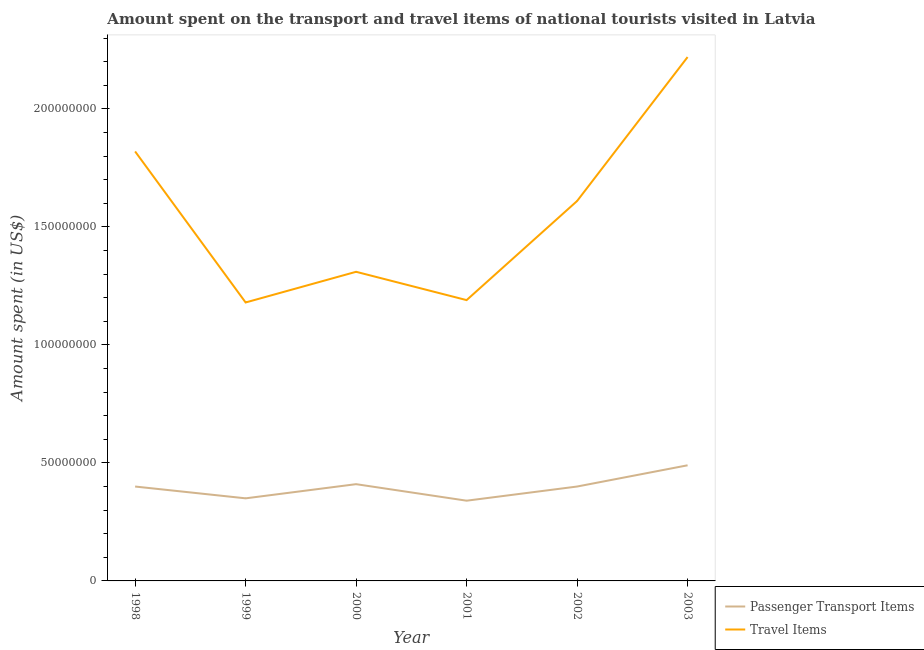Does the line corresponding to amount spent on passenger transport items intersect with the line corresponding to amount spent in travel items?
Your answer should be compact. No. What is the amount spent in travel items in 2000?
Keep it short and to the point. 1.31e+08. Across all years, what is the maximum amount spent in travel items?
Make the answer very short. 2.22e+08. Across all years, what is the minimum amount spent on passenger transport items?
Provide a succinct answer. 3.40e+07. In which year was the amount spent in travel items maximum?
Offer a very short reply. 2003. What is the total amount spent on passenger transport items in the graph?
Make the answer very short. 2.39e+08. What is the difference between the amount spent in travel items in 2000 and that in 2002?
Give a very brief answer. -3.00e+07. What is the difference between the amount spent on passenger transport items in 2002 and the amount spent in travel items in 2000?
Provide a short and direct response. -9.10e+07. What is the average amount spent on passenger transport items per year?
Give a very brief answer. 3.98e+07. In the year 2001, what is the difference between the amount spent on passenger transport items and amount spent in travel items?
Your answer should be compact. -8.50e+07. What is the ratio of the amount spent in travel items in 1998 to that in 2003?
Your answer should be very brief. 0.82. Is the difference between the amount spent in travel items in 2000 and 2001 greater than the difference between the amount spent on passenger transport items in 2000 and 2001?
Ensure brevity in your answer.  Yes. What is the difference between the highest and the second highest amount spent in travel items?
Keep it short and to the point. 4.00e+07. What is the difference between the highest and the lowest amount spent in travel items?
Offer a terse response. 1.04e+08. Is the sum of the amount spent on passenger transport items in 1998 and 2002 greater than the maximum amount spent in travel items across all years?
Your answer should be compact. No. Is the amount spent on passenger transport items strictly greater than the amount spent in travel items over the years?
Your response must be concise. No. What is the difference between two consecutive major ticks on the Y-axis?
Your answer should be compact. 5.00e+07. How many legend labels are there?
Ensure brevity in your answer.  2. What is the title of the graph?
Keep it short and to the point. Amount spent on the transport and travel items of national tourists visited in Latvia. Does "Research and Development" appear as one of the legend labels in the graph?
Provide a short and direct response. No. What is the label or title of the Y-axis?
Make the answer very short. Amount spent (in US$). What is the Amount spent (in US$) in Passenger Transport Items in 1998?
Your answer should be compact. 4.00e+07. What is the Amount spent (in US$) of Travel Items in 1998?
Your answer should be compact. 1.82e+08. What is the Amount spent (in US$) in Passenger Transport Items in 1999?
Your answer should be compact. 3.50e+07. What is the Amount spent (in US$) of Travel Items in 1999?
Offer a terse response. 1.18e+08. What is the Amount spent (in US$) of Passenger Transport Items in 2000?
Offer a terse response. 4.10e+07. What is the Amount spent (in US$) in Travel Items in 2000?
Offer a terse response. 1.31e+08. What is the Amount spent (in US$) of Passenger Transport Items in 2001?
Offer a very short reply. 3.40e+07. What is the Amount spent (in US$) in Travel Items in 2001?
Make the answer very short. 1.19e+08. What is the Amount spent (in US$) of Passenger Transport Items in 2002?
Provide a short and direct response. 4.00e+07. What is the Amount spent (in US$) of Travel Items in 2002?
Provide a short and direct response. 1.61e+08. What is the Amount spent (in US$) of Passenger Transport Items in 2003?
Your answer should be compact. 4.90e+07. What is the Amount spent (in US$) in Travel Items in 2003?
Provide a succinct answer. 2.22e+08. Across all years, what is the maximum Amount spent (in US$) in Passenger Transport Items?
Offer a terse response. 4.90e+07. Across all years, what is the maximum Amount spent (in US$) in Travel Items?
Give a very brief answer. 2.22e+08. Across all years, what is the minimum Amount spent (in US$) of Passenger Transport Items?
Give a very brief answer. 3.40e+07. Across all years, what is the minimum Amount spent (in US$) in Travel Items?
Give a very brief answer. 1.18e+08. What is the total Amount spent (in US$) in Passenger Transport Items in the graph?
Your response must be concise. 2.39e+08. What is the total Amount spent (in US$) in Travel Items in the graph?
Provide a short and direct response. 9.33e+08. What is the difference between the Amount spent (in US$) of Passenger Transport Items in 1998 and that in 1999?
Your answer should be compact. 5.00e+06. What is the difference between the Amount spent (in US$) of Travel Items in 1998 and that in 1999?
Your response must be concise. 6.40e+07. What is the difference between the Amount spent (in US$) in Passenger Transport Items in 1998 and that in 2000?
Give a very brief answer. -1.00e+06. What is the difference between the Amount spent (in US$) in Travel Items in 1998 and that in 2000?
Offer a terse response. 5.10e+07. What is the difference between the Amount spent (in US$) in Travel Items in 1998 and that in 2001?
Keep it short and to the point. 6.30e+07. What is the difference between the Amount spent (in US$) of Travel Items in 1998 and that in 2002?
Give a very brief answer. 2.10e+07. What is the difference between the Amount spent (in US$) of Passenger Transport Items in 1998 and that in 2003?
Your response must be concise. -9.00e+06. What is the difference between the Amount spent (in US$) of Travel Items in 1998 and that in 2003?
Provide a short and direct response. -4.00e+07. What is the difference between the Amount spent (in US$) in Passenger Transport Items in 1999 and that in 2000?
Offer a terse response. -6.00e+06. What is the difference between the Amount spent (in US$) in Travel Items in 1999 and that in 2000?
Provide a succinct answer. -1.30e+07. What is the difference between the Amount spent (in US$) of Travel Items in 1999 and that in 2001?
Give a very brief answer. -1.00e+06. What is the difference between the Amount spent (in US$) in Passenger Transport Items in 1999 and that in 2002?
Your answer should be compact. -5.00e+06. What is the difference between the Amount spent (in US$) of Travel Items in 1999 and that in 2002?
Provide a succinct answer. -4.30e+07. What is the difference between the Amount spent (in US$) in Passenger Transport Items in 1999 and that in 2003?
Give a very brief answer. -1.40e+07. What is the difference between the Amount spent (in US$) of Travel Items in 1999 and that in 2003?
Ensure brevity in your answer.  -1.04e+08. What is the difference between the Amount spent (in US$) of Passenger Transport Items in 2000 and that in 2002?
Give a very brief answer. 1.00e+06. What is the difference between the Amount spent (in US$) in Travel Items in 2000 and that in 2002?
Your response must be concise. -3.00e+07. What is the difference between the Amount spent (in US$) of Passenger Transport Items in 2000 and that in 2003?
Provide a succinct answer. -8.00e+06. What is the difference between the Amount spent (in US$) in Travel Items in 2000 and that in 2003?
Offer a very short reply. -9.10e+07. What is the difference between the Amount spent (in US$) in Passenger Transport Items in 2001 and that in 2002?
Your answer should be compact. -6.00e+06. What is the difference between the Amount spent (in US$) in Travel Items in 2001 and that in 2002?
Give a very brief answer. -4.20e+07. What is the difference between the Amount spent (in US$) of Passenger Transport Items in 2001 and that in 2003?
Your answer should be compact. -1.50e+07. What is the difference between the Amount spent (in US$) of Travel Items in 2001 and that in 2003?
Make the answer very short. -1.03e+08. What is the difference between the Amount spent (in US$) of Passenger Transport Items in 2002 and that in 2003?
Offer a terse response. -9.00e+06. What is the difference between the Amount spent (in US$) in Travel Items in 2002 and that in 2003?
Ensure brevity in your answer.  -6.10e+07. What is the difference between the Amount spent (in US$) in Passenger Transport Items in 1998 and the Amount spent (in US$) in Travel Items in 1999?
Give a very brief answer. -7.80e+07. What is the difference between the Amount spent (in US$) in Passenger Transport Items in 1998 and the Amount spent (in US$) in Travel Items in 2000?
Make the answer very short. -9.10e+07. What is the difference between the Amount spent (in US$) in Passenger Transport Items in 1998 and the Amount spent (in US$) in Travel Items in 2001?
Give a very brief answer. -7.90e+07. What is the difference between the Amount spent (in US$) of Passenger Transport Items in 1998 and the Amount spent (in US$) of Travel Items in 2002?
Give a very brief answer. -1.21e+08. What is the difference between the Amount spent (in US$) of Passenger Transport Items in 1998 and the Amount spent (in US$) of Travel Items in 2003?
Your answer should be very brief. -1.82e+08. What is the difference between the Amount spent (in US$) of Passenger Transport Items in 1999 and the Amount spent (in US$) of Travel Items in 2000?
Keep it short and to the point. -9.60e+07. What is the difference between the Amount spent (in US$) of Passenger Transport Items in 1999 and the Amount spent (in US$) of Travel Items in 2001?
Offer a very short reply. -8.40e+07. What is the difference between the Amount spent (in US$) of Passenger Transport Items in 1999 and the Amount spent (in US$) of Travel Items in 2002?
Ensure brevity in your answer.  -1.26e+08. What is the difference between the Amount spent (in US$) of Passenger Transport Items in 1999 and the Amount spent (in US$) of Travel Items in 2003?
Provide a succinct answer. -1.87e+08. What is the difference between the Amount spent (in US$) of Passenger Transport Items in 2000 and the Amount spent (in US$) of Travel Items in 2001?
Provide a short and direct response. -7.80e+07. What is the difference between the Amount spent (in US$) in Passenger Transport Items in 2000 and the Amount spent (in US$) in Travel Items in 2002?
Your response must be concise. -1.20e+08. What is the difference between the Amount spent (in US$) of Passenger Transport Items in 2000 and the Amount spent (in US$) of Travel Items in 2003?
Your answer should be compact. -1.81e+08. What is the difference between the Amount spent (in US$) of Passenger Transport Items in 2001 and the Amount spent (in US$) of Travel Items in 2002?
Keep it short and to the point. -1.27e+08. What is the difference between the Amount spent (in US$) of Passenger Transport Items in 2001 and the Amount spent (in US$) of Travel Items in 2003?
Offer a terse response. -1.88e+08. What is the difference between the Amount spent (in US$) in Passenger Transport Items in 2002 and the Amount spent (in US$) in Travel Items in 2003?
Keep it short and to the point. -1.82e+08. What is the average Amount spent (in US$) in Passenger Transport Items per year?
Provide a short and direct response. 3.98e+07. What is the average Amount spent (in US$) of Travel Items per year?
Ensure brevity in your answer.  1.56e+08. In the year 1998, what is the difference between the Amount spent (in US$) of Passenger Transport Items and Amount spent (in US$) of Travel Items?
Offer a very short reply. -1.42e+08. In the year 1999, what is the difference between the Amount spent (in US$) of Passenger Transport Items and Amount spent (in US$) of Travel Items?
Ensure brevity in your answer.  -8.30e+07. In the year 2000, what is the difference between the Amount spent (in US$) in Passenger Transport Items and Amount spent (in US$) in Travel Items?
Provide a succinct answer. -9.00e+07. In the year 2001, what is the difference between the Amount spent (in US$) in Passenger Transport Items and Amount spent (in US$) in Travel Items?
Offer a terse response. -8.50e+07. In the year 2002, what is the difference between the Amount spent (in US$) in Passenger Transport Items and Amount spent (in US$) in Travel Items?
Keep it short and to the point. -1.21e+08. In the year 2003, what is the difference between the Amount spent (in US$) in Passenger Transport Items and Amount spent (in US$) in Travel Items?
Provide a succinct answer. -1.73e+08. What is the ratio of the Amount spent (in US$) in Travel Items in 1998 to that in 1999?
Make the answer very short. 1.54. What is the ratio of the Amount spent (in US$) in Passenger Transport Items in 1998 to that in 2000?
Ensure brevity in your answer.  0.98. What is the ratio of the Amount spent (in US$) of Travel Items in 1998 to that in 2000?
Offer a very short reply. 1.39. What is the ratio of the Amount spent (in US$) in Passenger Transport Items in 1998 to that in 2001?
Offer a very short reply. 1.18. What is the ratio of the Amount spent (in US$) in Travel Items in 1998 to that in 2001?
Provide a succinct answer. 1.53. What is the ratio of the Amount spent (in US$) of Travel Items in 1998 to that in 2002?
Make the answer very short. 1.13. What is the ratio of the Amount spent (in US$) in Passenger Transport Items in 1998 to that in 2003?
Make the answer very short. 0.82. What is the ratio of the Amount spent (in US$) of Travel Items in 1998 to that in 2003?
Ensure brevity in your answer.  0.82. What is the ratio of the Amount spent (in US$) of Passenger Transport Items in 1999 to that in 2000?
Offer a terse response. 0.85. What is the ratio of the Amount spent (in US$) in Travel Items in 1999 to that in 2000?
Keep it short and to the point. 0.9. What is the ratio of the Amount spent (in US$) of Passenger Transport Items in 1999 to that in 2001?
Give a very brief answer. 1.03. What is the ratio of the Amount spent (in US$) of Travel Items in 1999 to that in 2001?
Make the answer very short. 0.99. What is the ratio of the Amount spent (in US$) of Passenger Transport Items in 1999 to that in 2002?
Offer a very short reply. 0.88. What is the ratio of the Amount spent (in US$) of Travel Items in 1999 to that in 2002?
Make the answer very short. 0.73. What is the ratio of the Amount spent (in US$) of Passenger Transport Items in 1999 to that in 2003?
Make the answer very short. 0.71. What is the ratio of the Amount spent (in US$) in Travel Items in 1999 to that in 2003?
Give a very brief answer. 0.53. What is the ratio of the Amount spent (in US$) in Passenger Transport Items in 2000 to that in 2001?
Offer a terse response. 1.21. What is the ratio of the Amount spent (in US$) of Travel Items in 2000 to that in 2001?
Keep it short and to the point. 1.1. What is the ratio of the Amount spent (in US$) of Travel Items in 2000 to that in 2002?
Ensure brevity in your answer.  0.81. What is the ratio of the Amount spent (in US$) in Passenger Transport Items in 2000 to that in 2003?
Provide a succinct answer. 0.84. What is the ratio of the Amount spent (in US$) in Travel Items in 2000 to that in 2003?
Provide a short and direct response. 0.59. What is the ratio of the Amount spent (in US$) of Travel Items in 2001 to that in 2002?
Provide a succinct answer. 0.74. What is the ratio of the Amount spent (in US$) of Passenger Transport Items in 2001 to that in 2003?
Keep it short and to the point. 0.69. What is the ratio of the Amount spent (in US$) in Travel Items in 2001 to that in 2003?
Your answer should be compact. 0.54. What is the ratio of the Amount spent (in US$) in Passenger Transport Items in 2002 to that in 2003?
Ensure brevity in your answer.  0.82. What is the ratio of the Amount spent (in US$) in Travel Items in 2002 to that in 2003?
Your answer should be very brief. 0.73. What is the difference between the highest and the second highest Amount spent (in US$) in Travel Items?
Offer a terse response. 4.00e+07. What is the difference between the highest and the lowest Amount spent (in US$) of Passenger Transport Items?
Your response must be concise. 1.50e+07. What is the difference between the highest and the lowest Amount spent (in US$) in Travel Items?
Your response must be concise. 1.04e+08. 